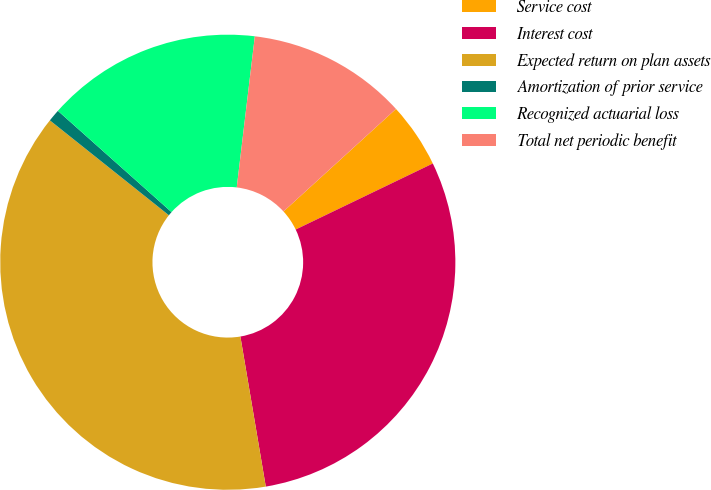Convert chart. <chart><loc_0><loc_0><loc_500><loc_500><pie_chart><fcel>Service cost<fcel>Interest cost<fcel>Expected return on plan assets<fcel>Amortization of prior service<fcel>Recognized actuarial loss<fcel>Total net periodic benefit<nl><fcel>4.62%<fcel>29.47%<fcel>38.38%<fcel>0.87%<fcel>15.31%<fcel>11.34%<nl></chart> 